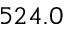<formula> <loc_0><loc_0><loc_500><loc_500>5 2 4 . 0</formula> 